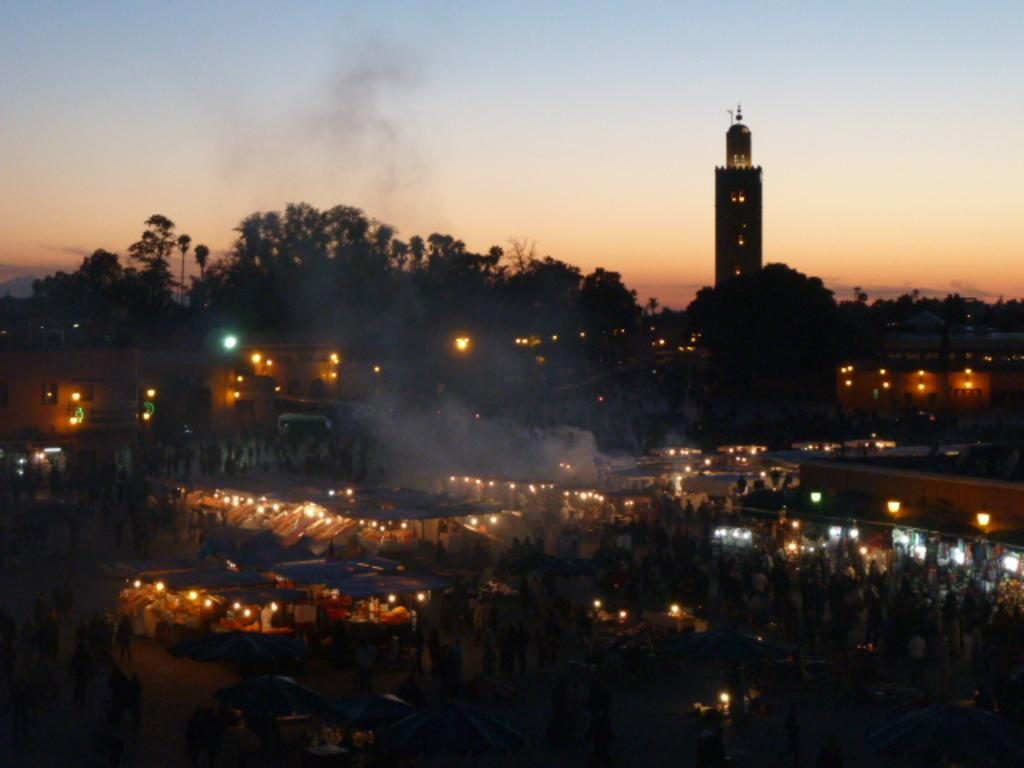What can be seen in the background of the image? There are tents and a tower in the background of the image. What is the condition of the sky in the image? The sky is clear in the background of the image. What are the persons near the tents doing? The provided facts do not specify what the persons near the tents are doing. Are there any visible light sources in the image? Yes, there are lights visible in the image. What type of lamp is placed on the ground in the image? There is no lamp present in the image. What decision did the persons near the tents make in the image? The provided facts do not specify any decisions made by the persons near the tents. 